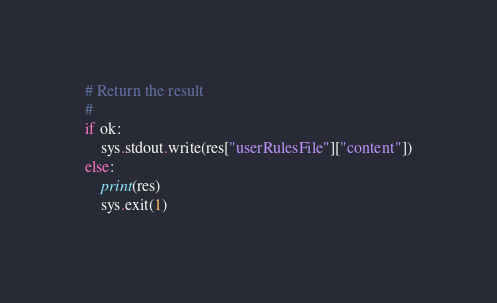<code> <loc_0><loc_0><loc_500><loc_500><_Python_># Return the result
#
if ok:
    sys.stdout.write(res["userRulesFile"]["content"])
else:
    print(res)
    sys.exit(1)
</code> 